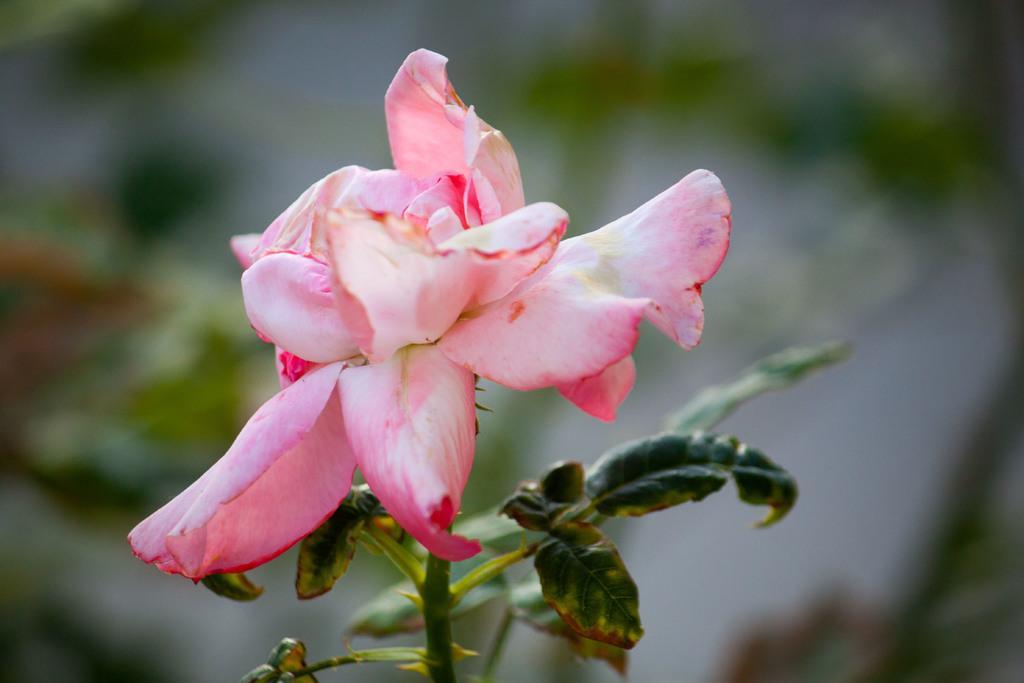Can you describe this image briefly? In this image we can see a flower to the stem of a plant. 